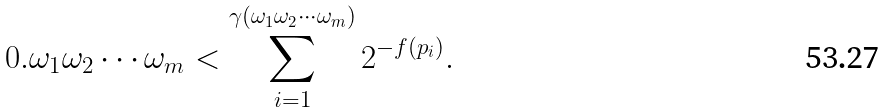Convert formula to latex. <formula><loc_0><loc_0><loc_500><loc_500>0 . \omega _ { 1 } \omega _ { 2 } \cdots \omega _ { m } < \sum _ { i = 1 } ^ { \gamma ( \omega _ { 1 } \omega _ { 2 } \cdots \omega _ { m } ) } 2 ^ { - f ( p _ { i } ) } .</formula> 